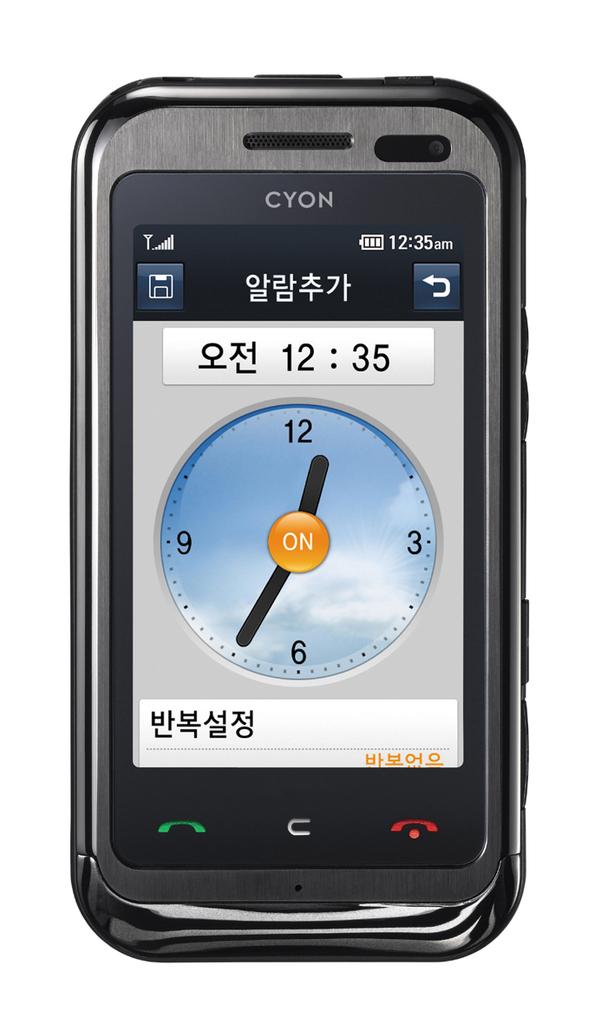12:35 a.m or p.m?
Provide a succinct answer. Am. What brand is the phone?
Your answer should be compact. Cyon. 